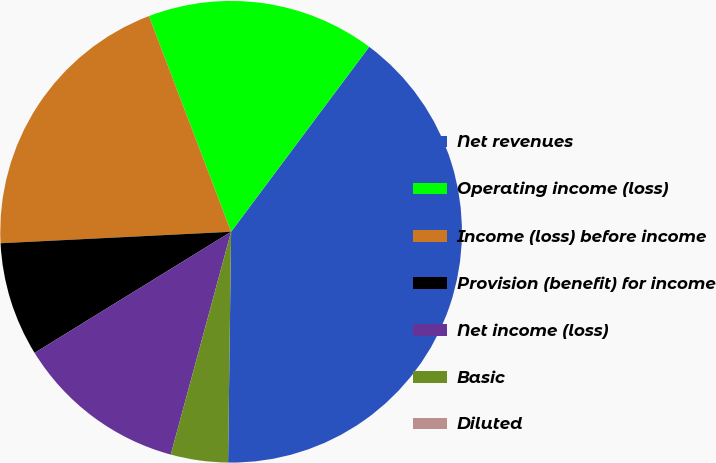<chart> <loc_0><loc_0><loc_500><loc_500><pie_chart><fcel>Net revenues<fcel>Operating income (loss)<fcel>Income (loss) before income<fcel>Provision (benefit) for income<fcel>Net income (loss)<fcel>Basic<fcel>Diluted<nl><fcel>40.0%<fcel>16.0%<fcel>20.0%<fcel>8.0%<fcel>12.0%<fcel>4.0%<fcel>0.0%<nl></chart> 